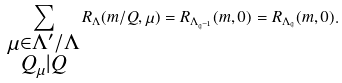Convert formula to latex. <formula><loc_0><loc_0><loc_500><loc_500>\sum _ { \substack { \mu \in \Lambda ^ { \prime } / \Lambda \\ Q _ { \mu } | Q } } R _ { \Lambda } ( m / Q , \mu ) = R _ { \Lambda _ { { \mathfrak q } ^ { - 1 } } } ( m , 0 ) = R _ { \Lambda _ { \mathfrak q } } ( m , 0 ) .</formula> 